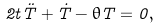Convert formula to latex. <formula><loc_0><loc_0><loc_500><loc_500>2 t \ddot { T } + \dot { T } - \theta T = 0 ,</formula> 